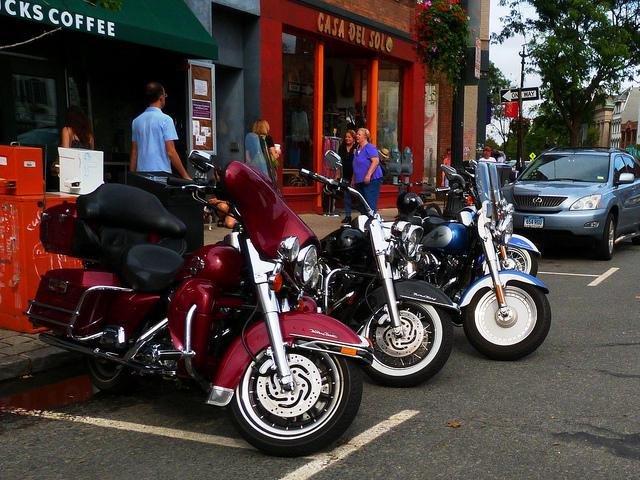What is the parent organization of the SUV? toyota 